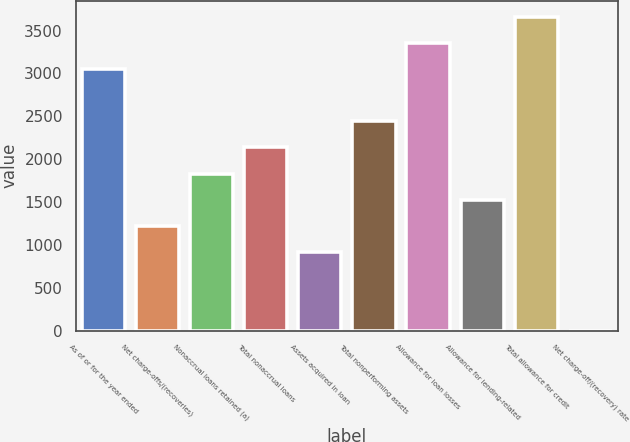Convert chart. <chart><loc_0><loc_0><loc_500><loc_500><bar_chart><fcel>As of or for the year ended<fcel>Net charge-offs/(recoveries)<fcel>Nonaccrual loans retained (a)<fcel>Total nonaccrual loans<fcel>Assets acquired in loan<fcel>Total nonperforming assets<fcel>Allowance for loan losses<fcel>Allowance for lending-related<fcel>Total allowance for credit<fcel>Net charge-off/(recovery) rate<nl><fcel>3053.01<fcel>1221.21<fcel>1831.81<fcel>2137.11<fcel>915.91<fcel>2442.41<fcel>3358.31<fcel>1526.51<fcel>3663.61<fcel>0.01<nl></chart> 